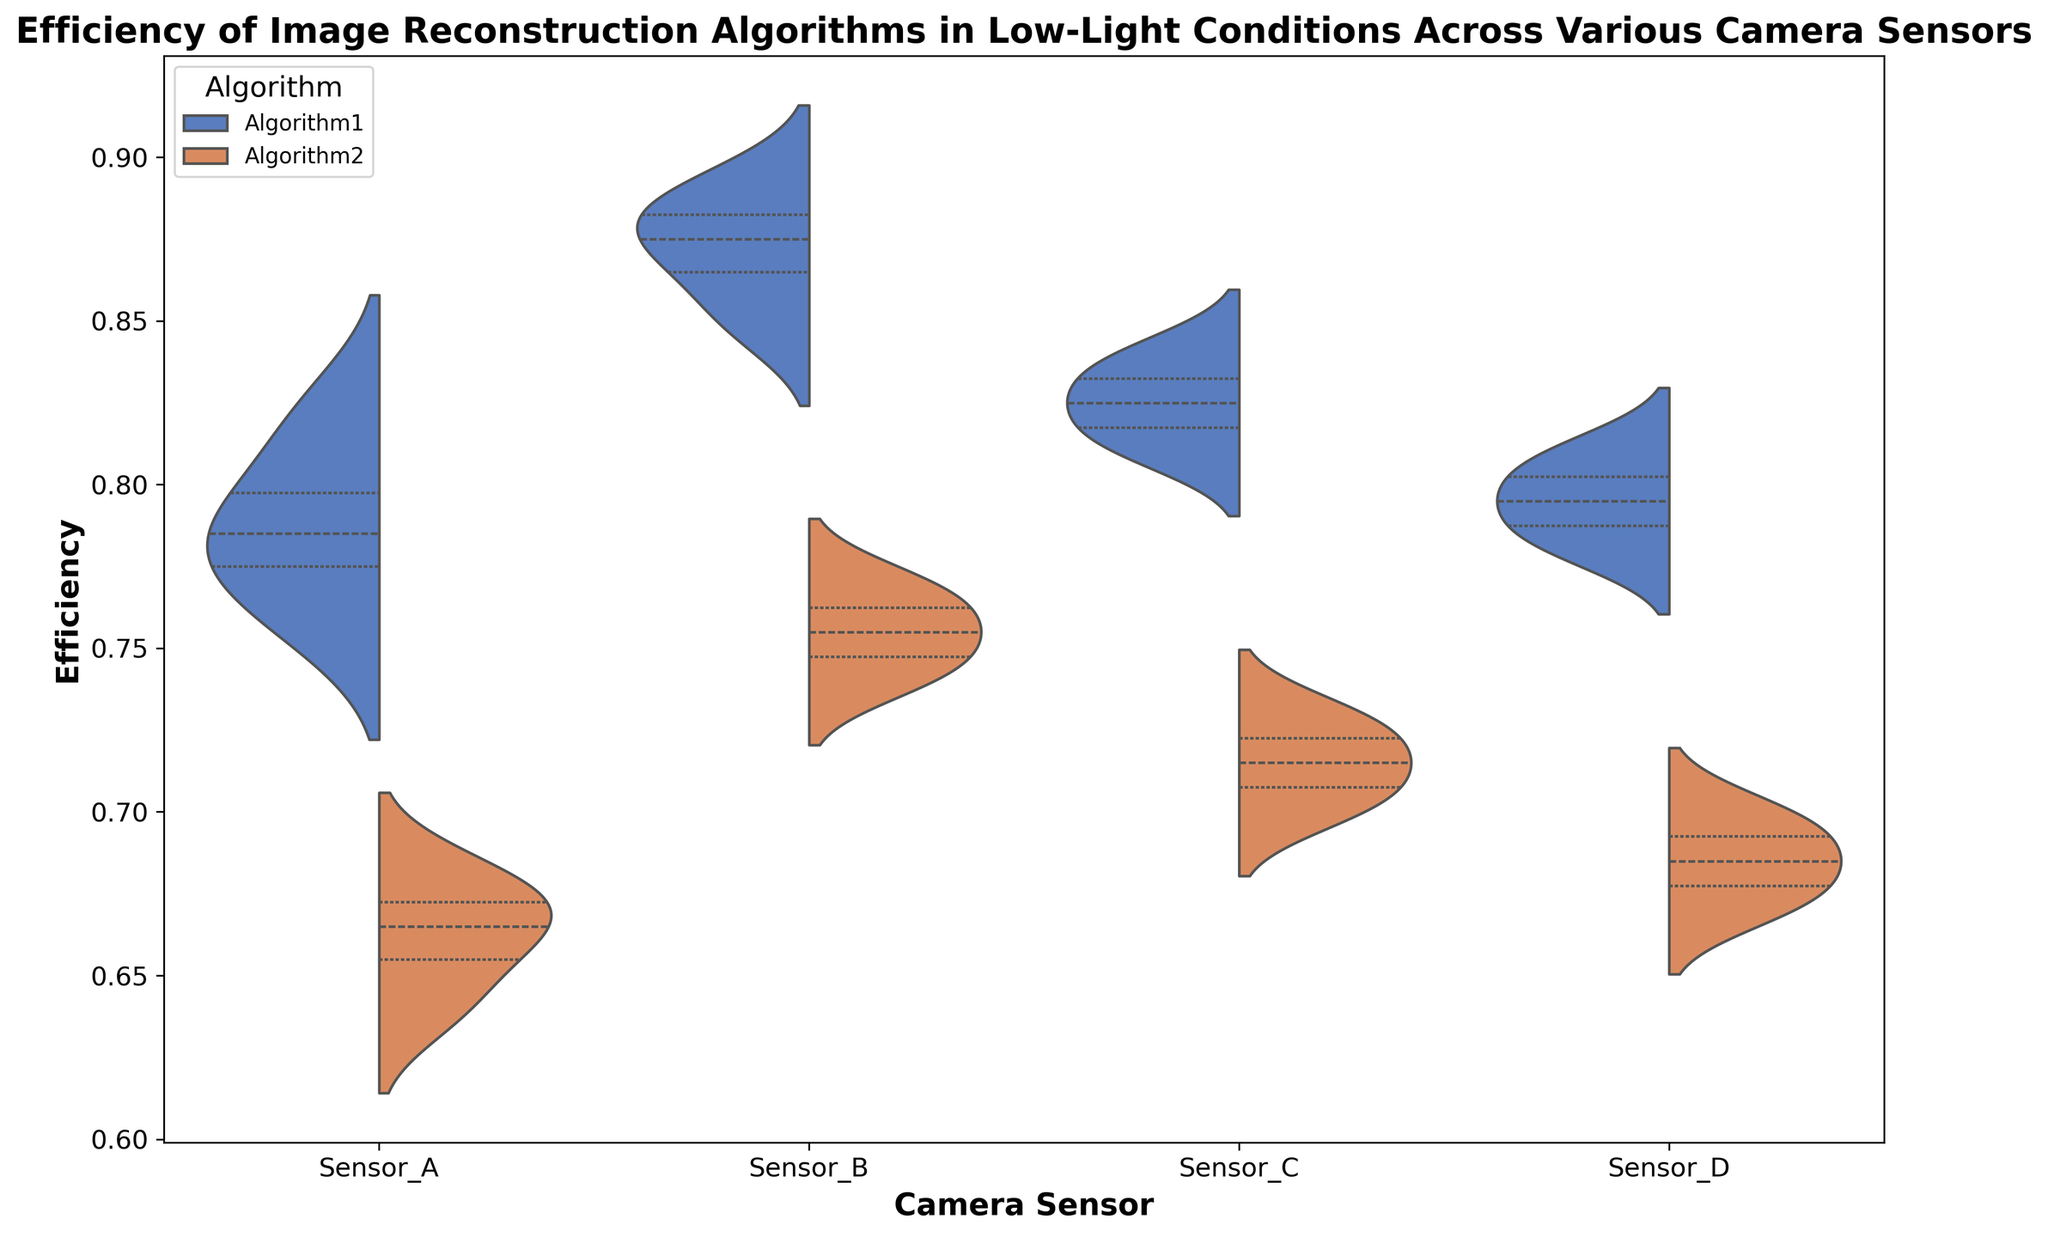Which camera sensor shows the highest efficiency for Algorithm1? Look at the peak of the violin plot for Algorithm1 across all camera sensors. Identify which sensor has the highest peak value. Sensor_B has the highest peak for Algorithm1.
Answer: Sensor_B Which camera sensor has the narrowest spread of efficiency values for Algorithm2? Look at the width of the violin plots for Algorithm2. The sensor with the narrowest plot indicates the least variability. Sensor_A has the narrowest spread for Algorithm2.
Answer: Sensor_A Between Algorithm1 and Algorithm2, which algorithm generally performs better across all camera sensors? Compare the peaks and central quartiles of the violin plots for both algorithms across all camera sensors. Algorithm1 generally has higher peaks and central values than Algorithm2.
Answer: Algorithm1 Is the median efficiency of Algorithm1 higher on Sensor_C or Sensor_D? Check the line inside the violin plots that represents the median for Algorithm1 on Sensor_C and Sensor_D. The line is higher for Sensor_C.
Answer: Sensor_C Which camera sensor has the least variability in efficiency for both algorithms combined? Evaluate the combined width of the violin plots (both Algorithm1 and Algorithm2) for each camera sensor, and identify the sensor with the smallest overall width. Sensor_A has the least variability for both algorithms combined.
Answer: Sensor_A Are there any camera sensors where Algorithm2 performs better than Algorithm1? Compare the violin plots for both algorithms across each camera sensor. Look for any plots where Algorithm2 has a higher peak or median compared to Algorithm1. No camera sensor demonstrates that Algorithm2 performs better than Algorithm1.
Answer: No For Sensor_B, what is the approximate difference between the median efficiencies of Algorithm1 and Algorithm2? Identify the median lines in the violin plots for Sensor_B for both algorithms, and calculate the difference. The median for Algorithm1 is about 0.87, and for Algorithm2, it is about 0.75. The difference is approximately 0.12.
Answer: 0.12 